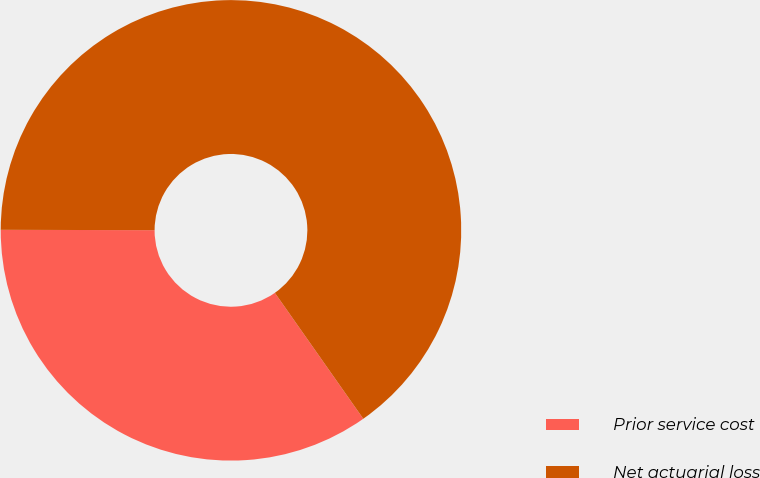Convert chart to OTSL. <chart><loc_0><loc_0><loc_500><loc_500><pie_chart><fcel>Prior service cost<fcel>Net actuarial loss<nl><fcel>34.78%<fcel>65.22%<nl></chart> 